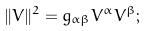<formula> <loc_0><loc_0><loc_500><loc_500>\| V \| ^ { 2 } = g _ { \alpha \beta } V ^ { \alpha } V ^ { \beta } ;</formula> 